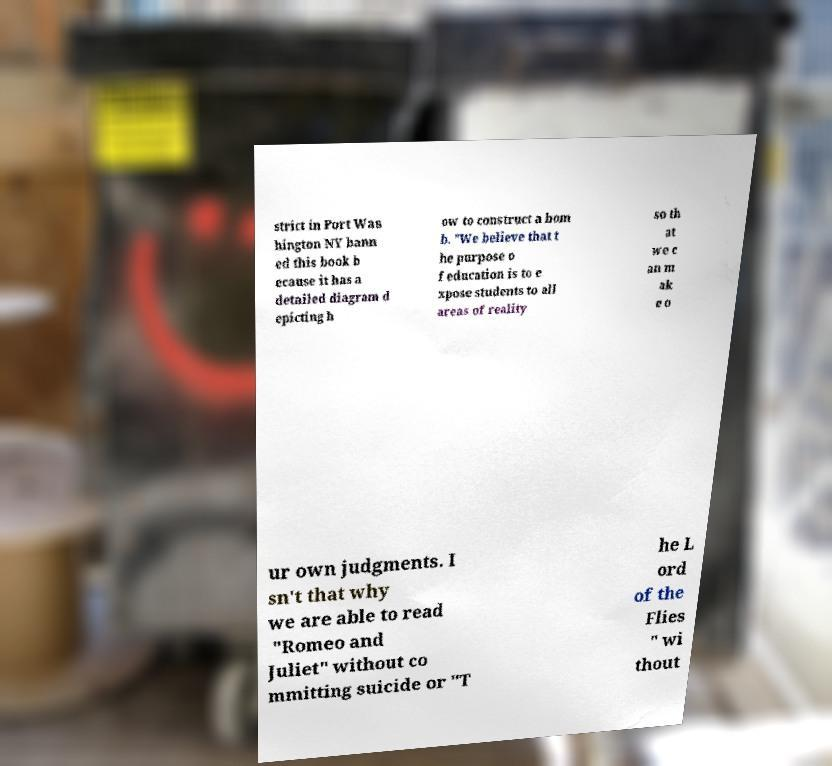Could you extract and type out the text from this image? strict in Port Was hington NY bann ed this book b ecause it has a detailed diagram d epicting h ow to construct a bom b. "We believe that t he purpose o f education is to e xpose students to all areas of reality so th at we c an m ak e o ur own judgments. I sn't that why we are able to read "Romeo and Juliet" without co mmitting suicide or "T he L ord of the Flies " wi thout 